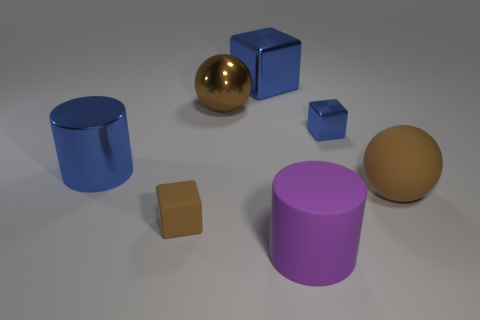Subtract all large blocks. How many blocks are left? 2 Subtract all gray cylinders. How many blue blocks are left? 2 Add 2 large cubes. How many objects exist? 9 Subtract all cylinders. How many objects are left? 5 Subtract 1 spheres. How many spheres are left? 1 Subtract all small brown matte cubes. Subtract all big purple matte cylinders. How many objects are left? 5 Add 7 blue cylinders. How many blue cylinders are left? 8 Add 6 small shiny objects. How many small shiny objects exist? 7 Subtract 0 red cylinders. How many objects are left? 7 Subtract all cyan cylinders. Subtract all cyan cubes. How many cylinders are left? 2 